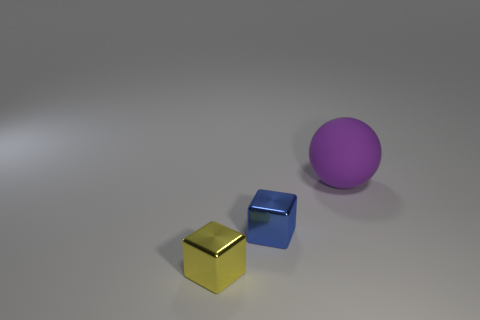Add 1 blue metallic cubes. How many objects exist? 4 Subtract all cubes. How many objects are left? 1 Add 1 big purple matte balls. How many big purple matte balls are left? 2 Add 2 tiny cyan objects. How many tiny cyan objects exist? 2 Subtract 1 yellow blocks. How many objects are left? 2 Subtract all tiny cyan cylinders. Subtract all tiny blue things. How many objects are left? 2 